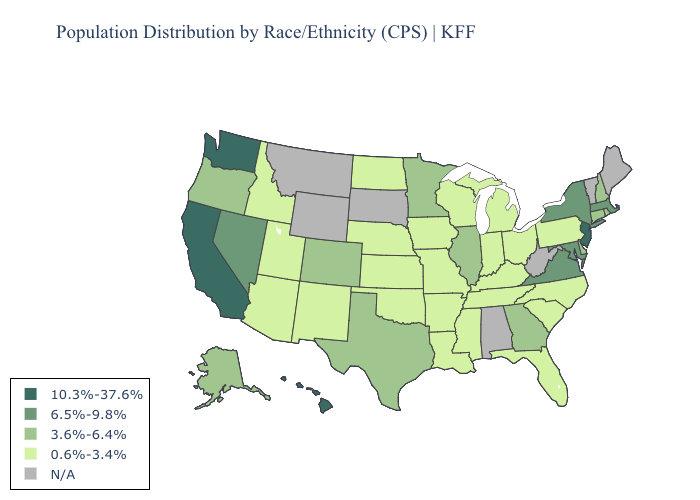What is the highest value in the USA?
Give a very brief answer. 10.3%-37.6%. What is the value of Montana?
Answer briefly. N/A. Name the states that have a value in the range 10.3%-37.6%?
Answer briefly. California, Hawaii, New Jersey, Washington. Does the map have missing data?
Concise answer only. Yes. Name the states that have a value in the range 6.5%-9.8%?
Answer briefly. Maryland, Massachusetts, Nevada, New York, Virginia. Name the states that have a value in the range N/A?
Keep it brief. Alabama, Maine, Montana, South Dakota, Vermont, West Virginia, Wyoming. Which states have the highest value in the USA?
Keep it brief. California, Hawaii, New Jersey, Washington. What is the value of Oklahoma?
Short answer required. 0.6%-3.4%. Which states have the lowest value in the Northeast?
Concise answer only. Pennsylvania. Name the states that have a value in the range 6.5%-9.8%?
Keep it brief. Maryland, Massachusetts, Nevada, New York, Virginia. What is the highest value in the Northeast ?
Write a very short answer. 10.3%-37.6%. Name the states that have a value in the range 6.5%-9.8%?
Short answer required. Maryland, Massachusetts, Nevada, New York, Virginia. Name the states that have a value in the range N/A?
Write a very short answer. Alabama, Maine, Montana, South Dakota, Vermont, West Virginia, Wyoming. What is the value of South Dakota?
Short answer required. N/A. 